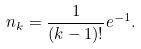Convert formula to latex. <formula><loc_0><loc_0><loc_500><loc_500>n _ { k } = \frac { 1 } { ( k - 1 ) ! } e ^ { - 1 } .</formula> 